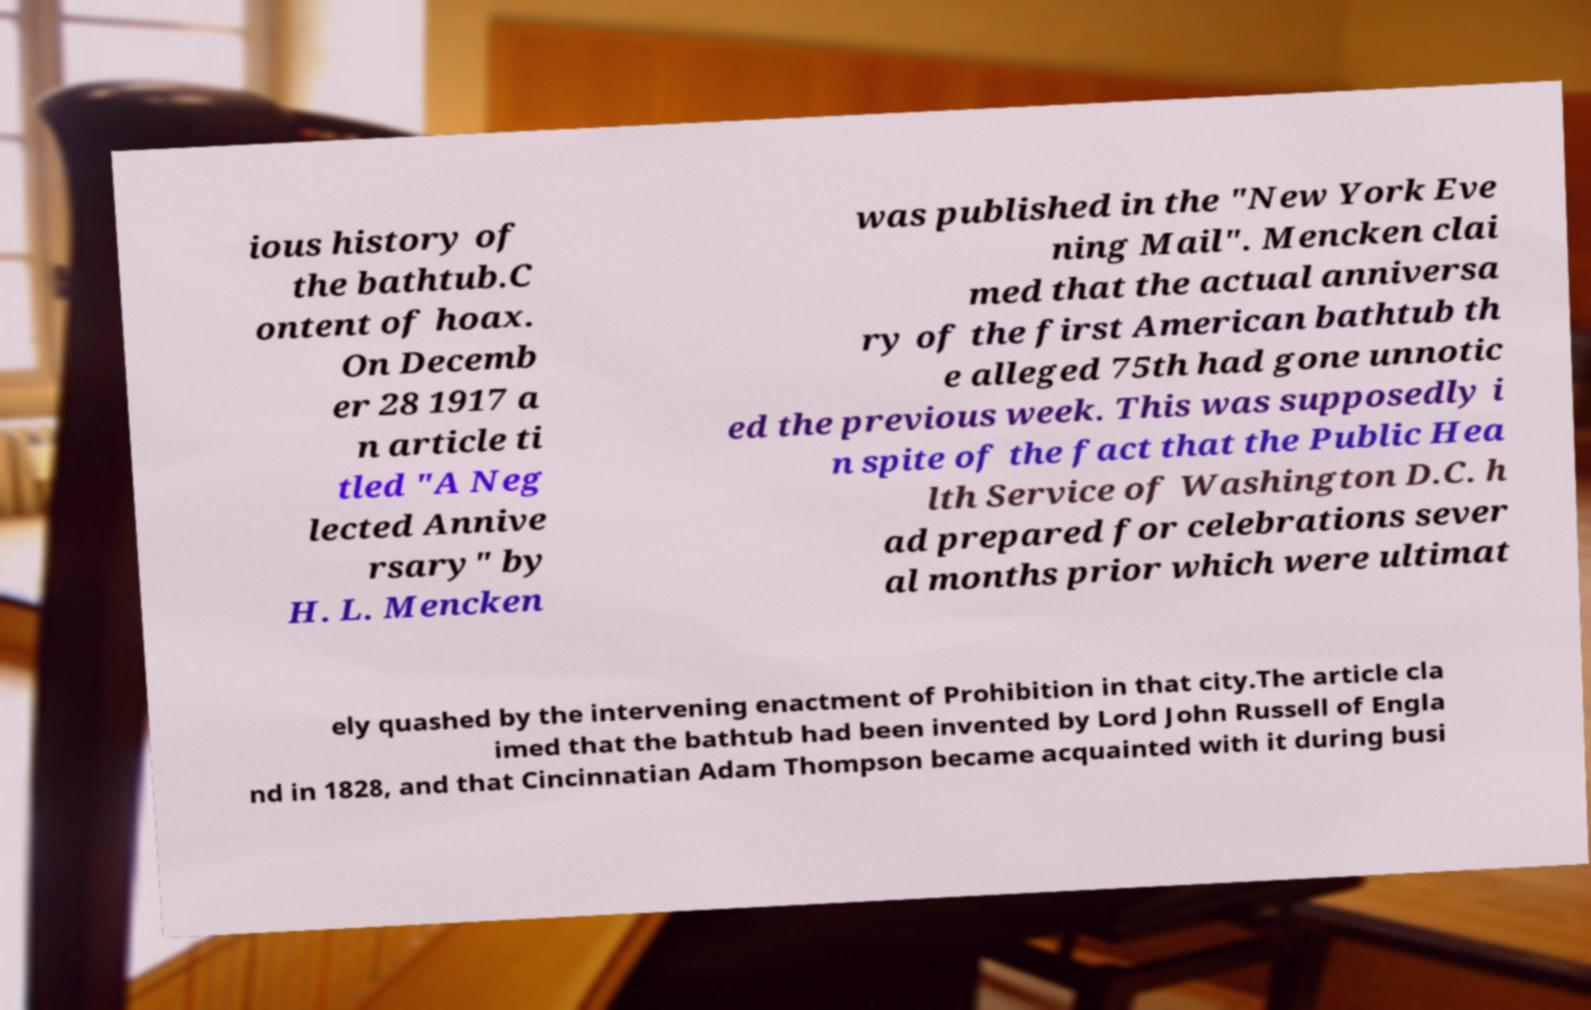I need the written content from this picture converted into text. Can you do that? ious history of the bathtub.C ontent of hoax. On Decemb er 28 1917 a n article ti tled "A Neg lected Annive rsary" by H. L. Mencken was published in the "New York Eve ning Mail". Mencken clai med that the actual anniversa ry of the first American bathtub th e alleged 75th had gone unnotic ed the previous week. This was supposedly i n spite of the fact that the Public Hea lth Service of Washington D.C. h ad prepared for celebrations sever al months prior which were ultimat ely quashed by the intervening enactment of Prohibition in that city.The article cla imed that the bathtub had been invented by Lord John Russell of Engla nd in 1828, and that Cincinnatian Adam Thompson became acquainted with it during busi 